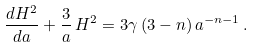<formula> <loc_0><loc_0><loc_500><loc_500>\frac { d H ^ { 2 } } { d a } + \frac { 3 } { a } \, H ^ { 2 } = 3 \gamma \, ( 3 - n ) \, a ^ { - n - 1 } \, .</formula> 